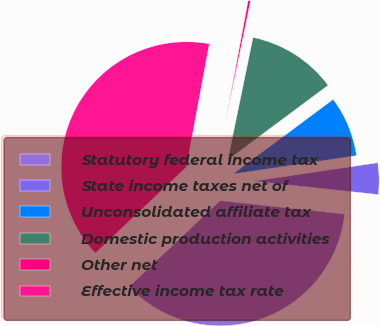Convert chart. <chart><loc_0><loc_0><loc_500><loc_500><pie_chart><fcel>Statutory federal income tax<fcel>State income taxes net of<fcel>Unconsolidated affiliate tax<fcel>Domestic production activities<fcel>Other net<fcel>Effective income tax rate<nl><fcel>36.23%<fcel>4.07%<fcel>7.83%<fcel>11.58%<fcel>0.31%<fcel>39.99%<nl></chart> 